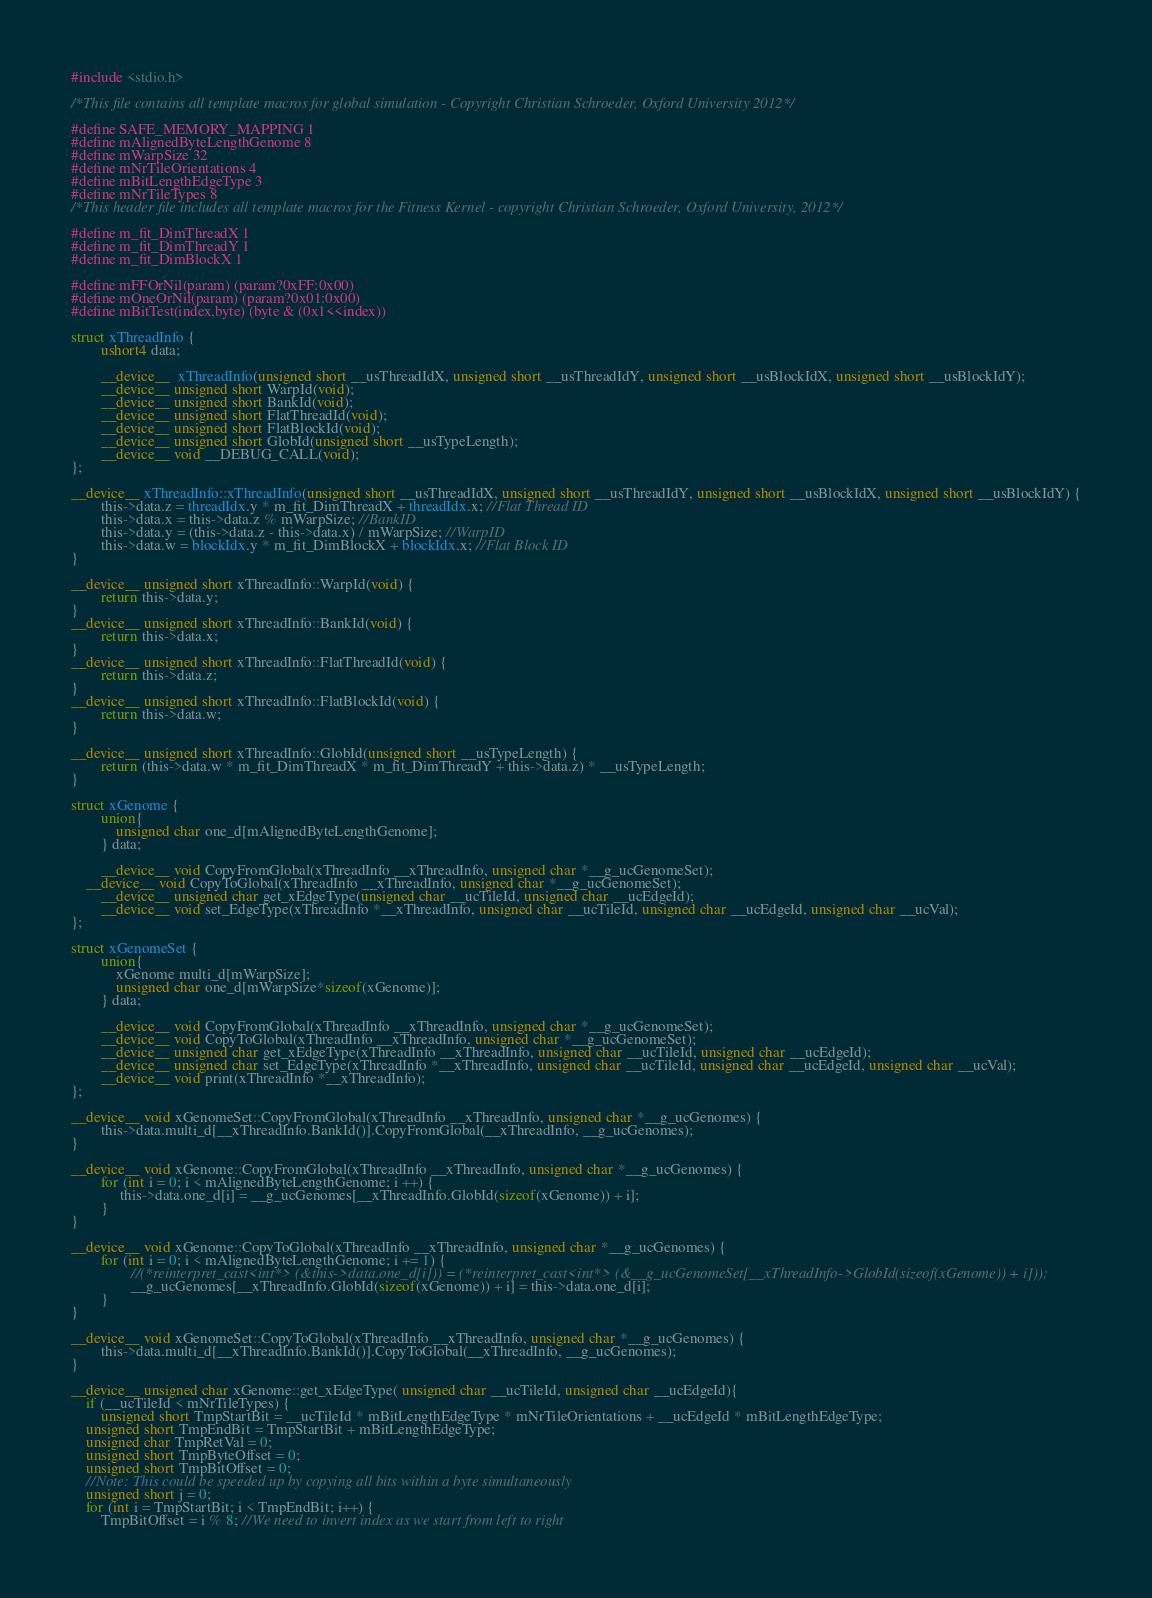Convert code to text. <code><loc_0><loc_0><loc_500><loc_500><_Cuda_>#include <stdio.h>

/*This file contains all template macros for global simulation - Copyright Christian Schroeder, Oxford University 2012*/

#define SAFE_MEMORY_MAPPING 1
#define mAlignedByteLengthGenome 8
#define mWarpSize 32
#define mNrTileOrientations 4
#define mBitLengthEdgeType 3
#define mNrTileTypes 8
/*This header file includes all template macros for the Fitness Kernel - copyright Christian Schroeder, Oxford University, 2012*/

#define m_fit_DimThreadX 1
#define m_fit_DimThreadY 1
#define m_fit_DimBlockX 1

#define mFFOrNil(param) (param?0xFF:0x00)
#define mOneOrNil(param) (param?0x01:0x00)
#define mBitTest(index,byte) (byte & (0x1<<index))

struct xThreadInfo {
        ushort4 data;
        
        __device__  xThreadInfo(unsigned short __usThreadIdX, unsigned short __usThreadIdY, unsigned short __usBlockIdX, unsigned short __usBlockIdY);
        __device__ unsigned short WarpId(void);
        __device__ unsigned short BankId(void);
        __device__ unsigned short FlatThreadId(void);
        __device__ unsigned short FlatBlockId(void);
        __device__ unsigned short GlobId(unsigned short __usTypeLength);
        __device__ void __DEBUG_CALL(void);
};

__device__ xThreadInfo::xThreadInfo(unsigned short __usThreadIdX, unsigned short __usThreadIdY, unsigned short __usBlockIdX, unsigned short __usBlockIdY) {
        this->data.z = threadIdx.y * m_fit_DimThreadX + threadIdx.x; //Flat Thread ID
        this->data.x = this->data.z % mWarpSize; //BankID
        this->data.y = (this->data.z - this->data.x) / mWarpSize; //WarpID
        this->data.w = blockIdx.y * m_fit_DimBlockX + blockIdx.x; //Flat Block ID
}

__device__ unsigned short xThreadInfo::WarpId(void) {
        return this->data.y;
}
__device__ unsigned short xThreadInfo::BankId(void) {
        return this->data.x;
}
__device__ unsigned short xThreadInfo::FlatThreadId(void) {
        return this->data.z;
}
__device__ unsigned short xThreadInfo::FlatBlockId(void) {
        return this->data.w;
}

__device__ unsigned short xThreadInfo::GlobId(unsigned short __usTypeLength) {
        return (this->data.w * m_fit_DimThreadX * m_fit_DimThreadY + this->data.z) * __usTypeLength;
}

struct xGenome {
        union{
            unsigned char one_d[mAlignedByteLengthGenome];
        } data;

        __device__ void CopyFromGlobal(xThreadInfo __xThreadInfo, unsigned char *__g_ucGenomeSet);
	__device__ void CopyToGlobal(xThreadInfo __xThreadInfo, unsigned char *__g_ucGenomeSet);
        __device__ unsigned char get_xEdgeType(unsigned char __ucTileId, unsigned char __ucEdgeId);
        __device__ void set_EdgeType(xThreadInfo *__xThreadInfo, unsigned char __ucTileId, unsigned char __ucEdgeId, unsigned char __ucVal);
};

struct xGenomeSet {
        union{        
            xGenome multi_d[mWarpSize];        
            unsigned char one_d[mWarpSize*sizeof(xGenome)];
        } data;

        __device__ void CopyFromGlobal(xThreadInfo __xThreadInfo, unsigned char *__g_ucGenomeSet);
        __device__ void CopyToGlobal(xThreadInfo __xThreadInfo, unsigned char *__g_ucGenomeSet);
        __device__ unsigned char get_xEdgeType(xThreadInfo __xThreadInfo, unsigned char __ucTileId, unsigned char __ucEdgeId);
        __device__ unsigned char set_EdgeType(xThreadInfo *__xThreadInfo, unsigned char __ucTileId, unsigned char __ucEdgeId, unsigned char __ucVal);
        __device__ void print(xThreadInfo *__xThreadInfo);
};

__device__ void xGenomeSet::CopyFromGlobal(xThreadInfo __xThreadInfo, unsigned char *__g_ucGenomes) {
        this->data.multi_d[__xThreadInfo.BankId()].CopyFromGlobal(__xThreadInfo, __g_ucGenomes);
}

__device__ void xGenome::CopyFromGlobal(xThreadInfo __xThreadInfo, unsigned char *__g_ucGenomes) {
        for (int i = 0; i < mAlignedByteLengthGenome; i ++) {
             this->data.one_d[i] = __g_ucGenomes[__xThreadInfo.GlobId(sizeof(xGenome)) + i];
        }
}

__device__ void xGenome::CopyToGlobal(xThreadInfo __xThreadInfo, unsigned char *__g_ucGenomes) {
        for (int i = 0; i < mAlignedByteLengthGenome; i += 1) {
                //(*reinterpret_cast<int*> (&this->data.one_d[i])) = (*reinterpret_cast<int*> (&__g_ucGenomeSet[__xThreadInfo->GlobId(sizeof(xGenome)) + i]));
                __g_ucGenomes[__xThreadInfo.GlobId(sizeof(xGenome)) + i] = this->data.one_d[i];
        }
}

__device__ void xGenomeSet::CopyToGlobal(xThreadInfo __xThreadInfo, unsigned char *__g_ucGenomes) {
        this->data.multi_d[__xThreadInfo.BankId()].CopyToGlobal(__xThreadInfo, __g_ucGenomes);
}

__device__ unsigned char xGenome::get_xEdgeType( unsigned char __ucTileId, unsigned char __ucEdgeId){
    if (__ucTileId < mNrTileTypes) {
        unsigned short TmpStartBit = __ucTileId * mBitLengthEdgeType * mNrTileOrientations + __ucEdgeId * mBitLengthEdgeType;
	unsigned short TmpEndBit = TmpStartBit + mBitLengthEdgeType;
	unsigned char TmpRetVal = 0;
	unsigned short TmpByteOffset = 0;
	unsigned short TmpBitOffset = 0;
	//Note: This could be speeded up by copying all bits within a byte simultaneously
	unsigned short j = 0;
	for (int i = TmpStartBit; i < TmpEndBit; i++) {
	    TmpBitOffset = i % 8; //We need to invert index as we start from left to right</code> 